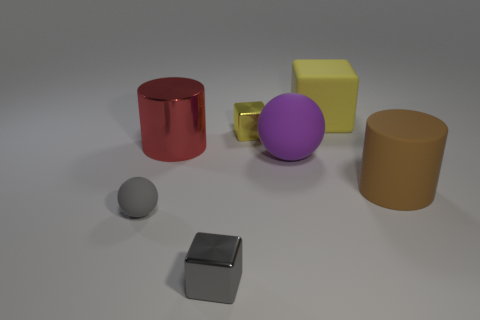How many yellow blocks must be subtracted to get 1 yellow blocks? 1 Add 2 tiny cyan matte spheres. How many objects exist? 9 Subtract all cylinders. How many objects are left? 5 Subtract all small yellow blocks. Subtract all small yellow objects. How many objects are left? 5 Add 1 tiny gray metallic things. How many tiny gray metallic things are left? 2 Add 4 gray balls. How many gray balls exist? 5 Subtract 0 brown spheres. How many objects are left? 7 